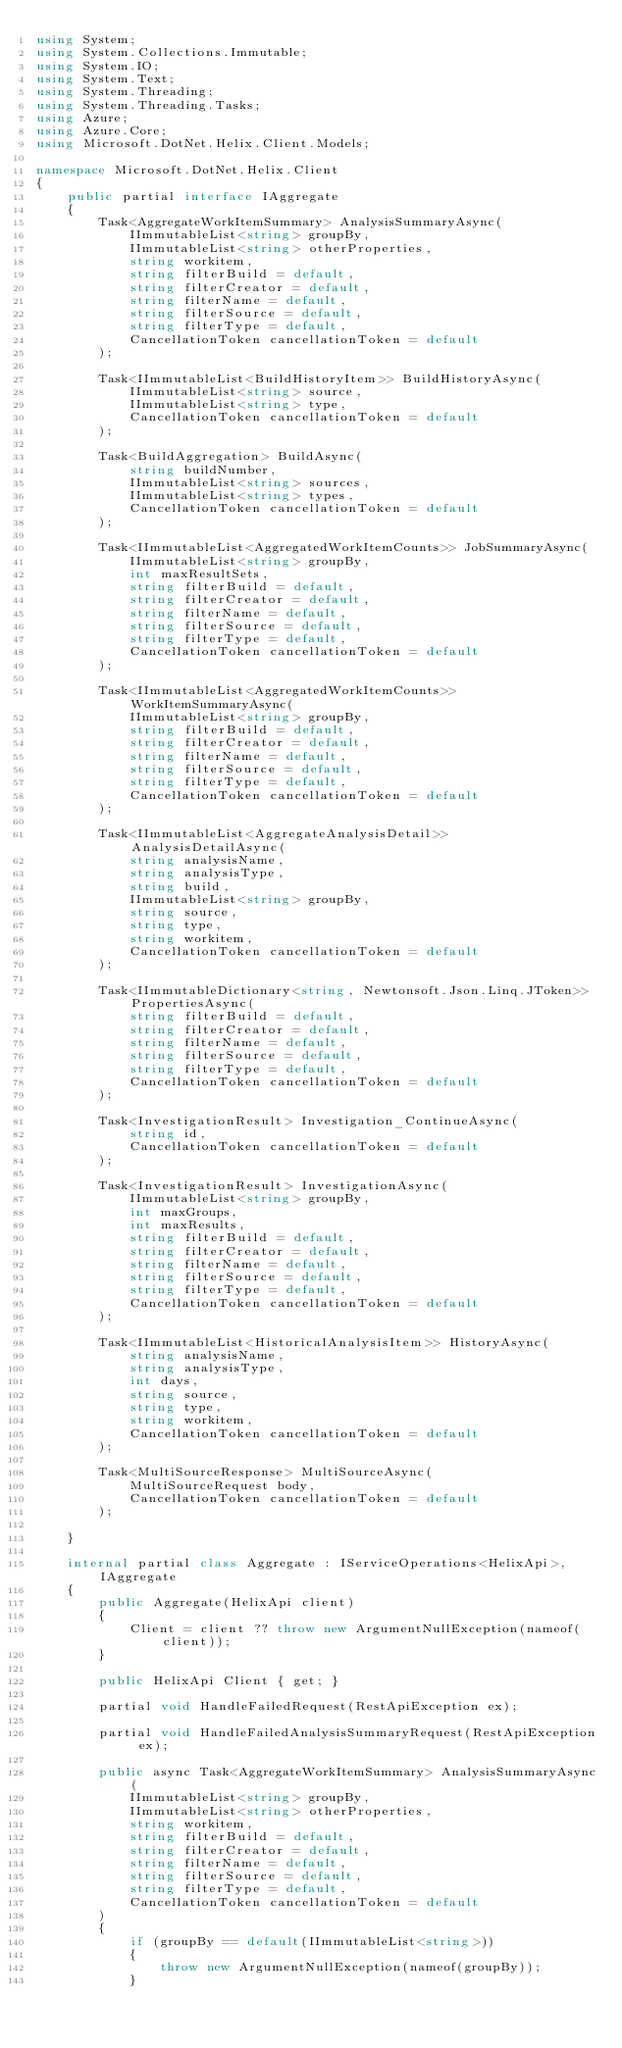Convert code to text. <code><loc_0><loc_0><loc_500><loc_500><_C#_>using System;
using System.Collections.Immutable;
using System.IO;
using System.Text;
using System.Threading;
using System.Threading.Tasks;
using Azure;
using Azure.Core;
using Microsoft.DotNet.Helix.Client.Models;

namespace Microsoft.DotNet.Helix.Client
{
    public partial interface IAggregate
    {
        Task<AggregateWorkItemSummary> AnalysisSummaryAsync(
            IImmutableList<string> groupBy,
            IImmutableList<string> otherProperties,
            string workitem,
            string filterBuild = default,
            string filterCreator = default,
            string filterName = default,
            string filterSource = default,
            string filterType = default,
            CancellationToken cancellationToken = default
        );

        Task<IImmutableList<BuildHistoryItem>> BuildHistoryAsync(
            IImmutableList<string> source,
            IImmutableList<string> type,
            CancellationToken cancellationToken = default
        );

        Task<BuildAggregation> BuildAsync(
            string buildNumber,
            IImmutableList<string> sources,
            IImmutableList<string> types,
            CancellationToken cancellationToken = default
        );

        Task<IImmutableList<AggregatedWorkItemCounts>> JobSummaryAsync(
            IImmutableList<string> groupBy,
            int maxResultSets,
            string filterBuild = default,
            string filterCreator = default,
            string filterName = default,
            string filterSource = default,
            string filterType = default,
            CancellationToken cancellationToken = default
        );

        Task<IImmutableList<AggregatedWorkItemCounts>> WorkItemSummaryAsync(
            IImmutableList<string> groupBy,
            string filterBuild = default,
            string filterCreator = default,
            string filterName = default,
            string filterSource = default,
            string filterType = default,
            CancellationToken cancellationToken = default
        );

        Task<IImmutableList<AggregateAnalysisDetail>> AnalysisDetailAsync(
            string analysisName,
            string analysisType,
            string build,
            IImmutableList<string> groupBy,
            string source,
            string type,
            string workitem,
            CancellationToken cancellationToken = default
        );

        Task<IImmutableDictionary<string, Newtonsoft.Json.Linq.JToken>> PropertiesAsync(
            string filterBuild = default,
            string filterCreator = default,
            string filterName = default,
            string filterSource = default,
            string filterType = default,
            CancellationToken cancellationToken = default
        );

        Task<InvestigationResult> Investigation_ContinueAsync(
            string id,
            CancellationToken cancellationToken = default
        );

        Task<InvestigationResult> InvestigationAsync(
            IImmutableList<string> groupBy,
            int maxGroups,
            int maxResults,
            string filterBuild = default,
            string filterCreator = default,
            string filterName = default,
            string filterSource = default,
            string filterType = default,
            CancellationToken cancellationToken = default
        );

        Task<IImmutableList<HistoricalAnalysisItem>> HistoryAsync(
            string analysisName,
            string analysisType,
            int days,
            string source,
            string type,
            string workitem,
            CancellationToken cancellationToken = default
        );

        Task<MultiSourceResponse> MultiSourceAsync(
            MultiSourceRequest body,
            CancellationToken cancellationToken = default
        );

    }

    internal partial class Aggregate : IServiceOperations<HelixApi>, IAggregate
    {
        public Aggregate(HelixApi client)
        {
            Client = client ?? throw new ArgumentNullException(nameof(client));
        }

        public HelixApi Client { get; }

        partial void HandleFailedRequest(RestApiException ex);

        partial void HandleFailedAnalysisSummaryRequest(RestApiException ex);

        public async Task<AggregateWorkItemSummary> AnalysisSummaryAsync(
            IImmutableList<string> groupBy,
            IImmutableList<string> otherProperties,
            string workitem,
            string filterBuild = default,
            string filterCreator = default,
            string filterName = default,
            string filterSource = default,
            string filterType = default,
            CancellationToken cancellationToken = default
        )
        {
            if (groupBy == default(IImmutableList<string>))
            {
                throw new ArgumentNullException(nameof(groupBy));
            }
</code> 